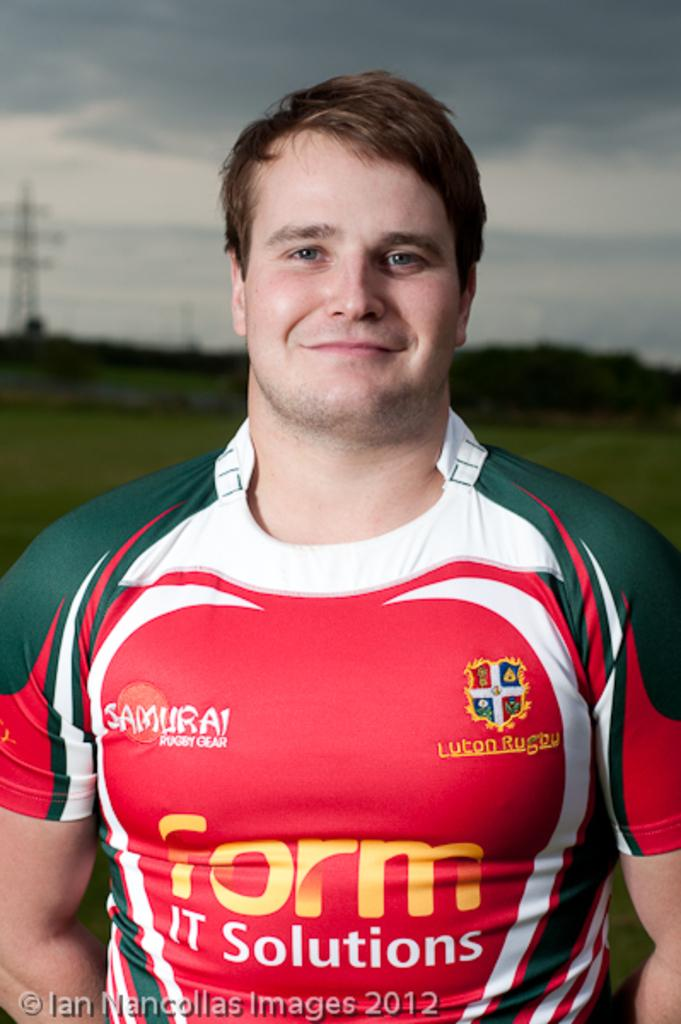Provide a one-sentence caption for the provided image. A man has on a green,white and red shirt with form it solutions written in front. 